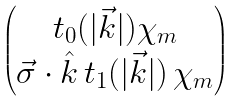<formula> <loc_0><loc_0><loc_500><loc_500>\begin{pmatrix} t _ { 0 } ( | \vec { k } | ) \chi _ { m } \\ { \vec { \sigma } \cdot \hat { k } } \, t _ { 1 } ( | \vec { k } | ) \, \chi _ { m } \end{pmatrix}</formula> 